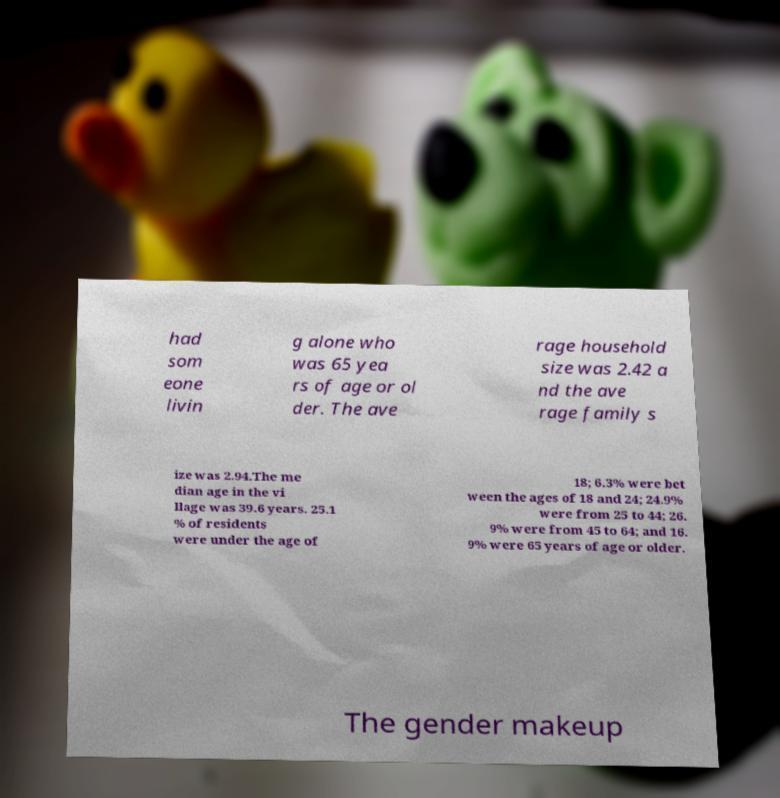Could you assist in decoding the text presented in this image and type it out clearly? had som eone livin g alone who was 65 yea rs of age or ol der. The ave rage household size was 2.42 a nd the ave rage family s ize was 2.94.The me dian age in the vi llage was 39.6 years. 25.1 % of residents were under the age of 18; 6.3% were bet ween the ages of 18 and 24; 24.9% were from 25 to 44; 26. 9% were from 45 to 64; and 16. 9% were 65 years of age or older. The gender makeup 